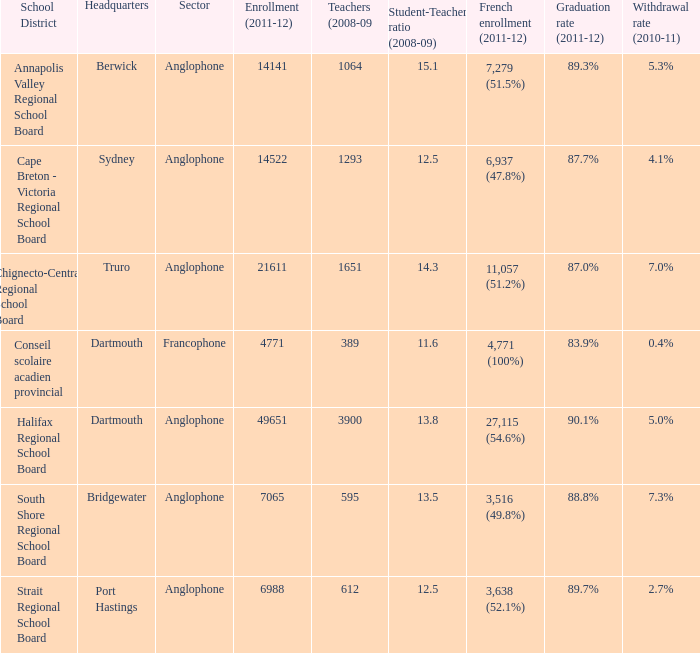What is the graduation rate for the school district with headquarters located in Sydney? 87.7%. 